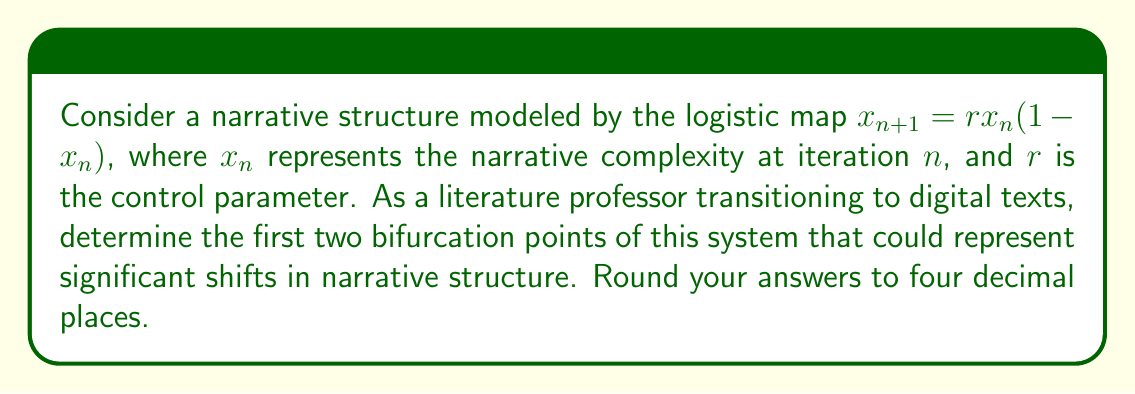Give your solution to this math problem. To find the bifurcation points in this narrative structure model, we need to analyze the behavior of the logistic map as the control parameter $r$ increases:

1. For $0 \leq r \leq 1$, the system converges to 0, representing a simple, linear narrative.

2. The first bifurcation occurs when $r > 1$. At this point, the system has a non-zero fixed point:

   $$x^* = rx^*(1-x^*)$$
   $$x^* = 1 - \frac{1}{r}$$

3. This fixed point is stable until $r$ reaches 3. At $r = 3$, the system undergoes its first period-doubling bifurcation. This is our first bifurcation point.

4. To find the second bifurcation point, we need to analyze the stability of the period-2 cycle. The period-2 cycle becomes unstable when:

   $$\left|\frac{d}{dx}(f(f(x)))\right|_{x=x^*} = 1$$

   Where $f(x) = rx(1-x)$

5. Solving this equation:

   $$\left|r^2(1-2x^*)(1-2f(x^*))\right| = 1$$

6. After substituting and solving, we get:

   $$r \approx 3.4494897$$

This is the second bifurcation point, representing another significant shift in narrative complexity.

These bifurcation points can be interpreted as critical thresholds where the narrative structure undergoes fundamental changes, potentially reflecting the transition from linear to non-linear storytelling in digital literature.
Answer: First bifurcation point: 3.0000
Second bifurcation point: 3.4495 